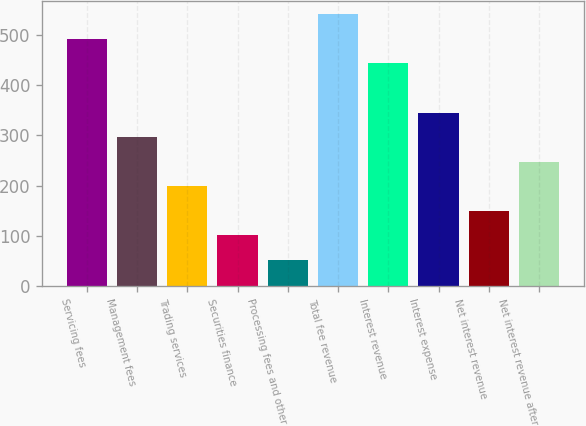Convert chart. <chart><loc_0><loc_0><loc_500><loc_500><bar_chart><fcel>Servicing fees<fcel>Management fees<fcel>Trading services<fcel>Securities finance<fcel>Processing fees and other<fcel>Total fee revenue<fcel>Interest revenue<fcel>Interest expense<fcel>Net interest revenue<fcel>Net interest revenue after<nl><fcel>492<fcel>296.4<fcel>198.6<fcel>100.8<fcel>51.9<fcel>540.9<fcel>443.1<fcel>345.3<fcel>149.7<fcel>247.5<nl></chart> 